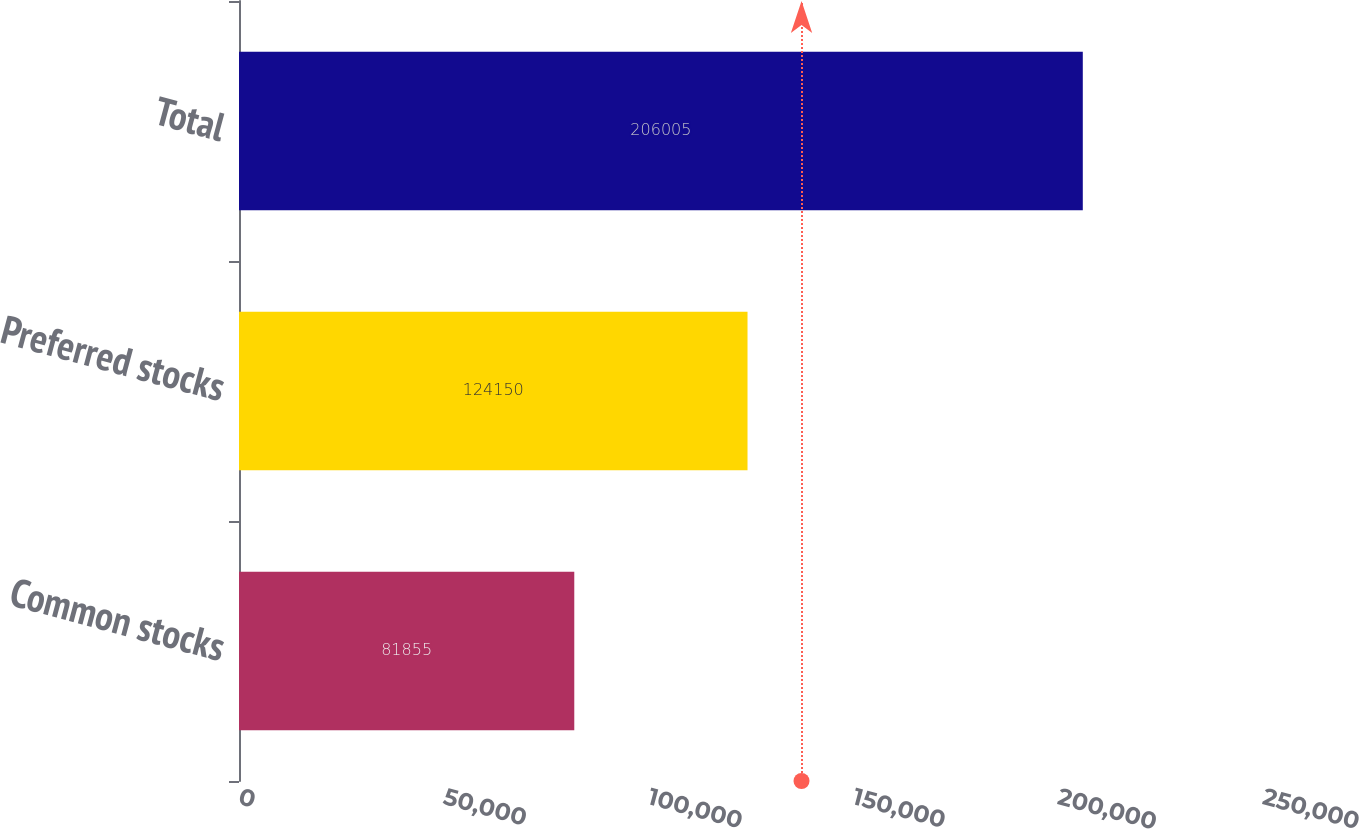Convert chart. <chart><loc_0><loc_0><loc_500><loc_500><bar_chart><fcel>Common stocks<fcel>Preferred stocks<fcel>Total<nl><fcel>81855<fcel>124150<fcel>206005<nl></chart> 